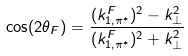Convert formula to latex. <formula><loc_0><loc_0><loc_500><loc_500>\cos ( 2 \theta _ { F } ) = \frac { ( k ^ { F } _ { 1 , \pi ^ { * } } ) ^ { 2 } - k _ { \perp } ^ { 2 } } { ( k ^ { F } _ { 1 , \pi ^ { * } } ) ^ { 2 } + k _ { \perp } ^ { 2 } }</formula> 